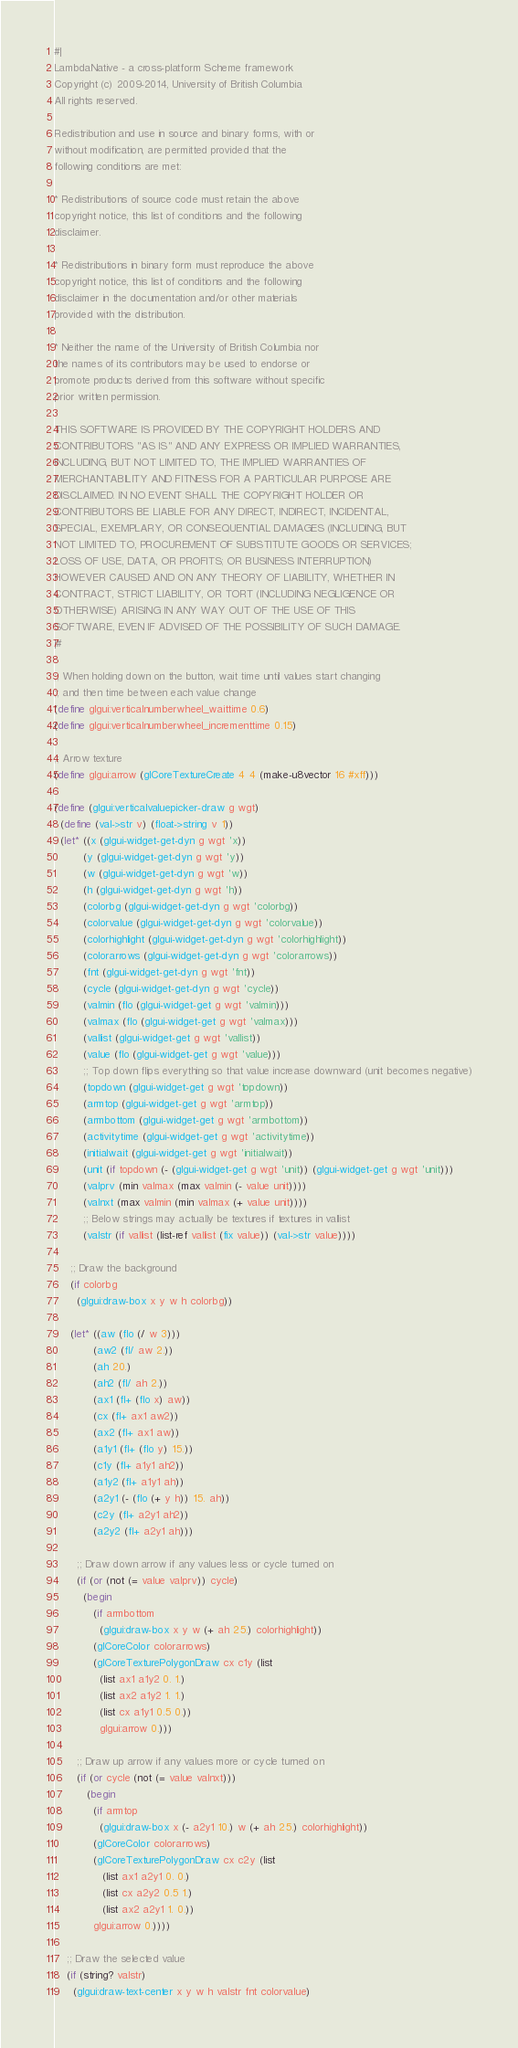<code> <loc_0><loc_0><loc_500><loc_500><_Scheme_>#|
LambdaNative - a cross-platform Scheme framework
Copyright (c) 2009-2014, University of British Columbia
All rights reserved.

Redistribution and use in source and binary forms, with or
without modification, are permitted provided that the
following conditions are met:

* Redistributions of source code must retain the above
copyright notice, this list of conditions and the following
disclaimer.

* Redistributions in binary form must reproduce the above
copyright notice, this list of conditions and the following
disclaimer in the documentation and/or other materials
provided with the distribution.

* Neither the name of the University of British Columbia nor
the names of its contributors may be used to endorse or
promote products derived from this software without specific
prior written permission.

THIS SOFTWARE IS PROVIDED BY THE COPYRIGHT HOLDERS AND
CONTRIBUTORS "AS IS" AND ANY EXPRESS OR IMPLIED WARRANTIES,
INCLUDING, BUT NOT LIMITED TO, THE IMPLIED WARRANTIES OF
MERCHANTABILITY AND FITNESS FOR A PARTICULAR PURPOSE ARE
DISCLAIMED. IN NO EVENT SHALL THE COPYRIGHT HOLDER OR
CONTRIBUTORS BE LIABLE FOR ANY DIRECT, INDIRECT, INCIDENTAL,
SPECIAL, EXEMPLARY, OR CONSEQUENTIAL DAMAGES (INCLUDING, BUT
NOT LIMITED TO, PROCUREMENT OF SUBSTITUTE GOODS OR SERVICES;
LOSS OF USE, DATA, OR PROFITS; OR BUSINESS INTERRUPTION)
HOWEVER CAUSED AND ON ANY THEORY OF LIABILITY, WHETHER IN
CONTRACT, STRICT LIABILITY, OR TORT (INCLUDING NEGLIGENCE OR
OTHERWISE) ARISING IN ANY WAY OUT OF THE USE OF THIS
SOFTWARE, EVEN IF ADVISED OF THE POSSIBILITY OF SUCH DAMAGE.
|#

;; When holding down on the button, wait time until values start changing
;; and then time between each value change 
(define glgui:verticalnumberwheel_waittime 0.6)
(define glgui:verticalnumberwheel_incrementtime 0.15)

;; Arrow texture
(define glgui:arrow (glCoreTextureCreate 4 4 (make-u8vector 16 #xff)))

(define (glgui:verticalvaluepicker-draw g wgt)
  (define (val->str v) (float->string v 1))
  (let* ((x (glgui-widget-get-dyn g wgt 'x))
         (y (glgui-widget-get-dyn g wgt 'y))
         (w (glgui-widget-get-dyn g wgt 'w))
         (h (glgui-widget-get-dyn g wgt 'h))
         (colorbg (glgui-widget-get-dyn g wgt 'colorbg))
         (colorvalue (glgui-widget-get-dyn g wgt 'colorvalue))
         (colorhighlight (glgui-widget-get-dyn g wgt 'colorhighlight))
         (colorarrows (glgui-widget-get-dyn g wgt 'colorarrows))
         (fnt (glgui-widget-get-dyn g wgt 'fnt))
         (cycle (glgui-widget-get-dyn g wgt 'cycle))
         (valmin (flo (glgui-widget-get g wgt 'valmin)))
         (valmax (flo (glgui-widget-get g wgt 'valmax)))
         (vallist (glgui-widget-get g wgt 'vallist))
         (value (flo (glgui-widget-get g wgt 'value)))
         ;; Top down flips everything so that value increase downward (unit becomes negative)
         (topdown (glgui-widget-get g wgt 'topdown))
         (armtop (glgui-widget-get g wgt 'armtop))
         (armbottom (glgui-widget-get g wgt 'armbottom))
         (activitytime (glgui-widget-get g wgt 'activitytime))
         (initialwait (glgui-widget-get g wgt 'initialwait))
         (unit (if topdown (- (glgui-widget-get g wgt 'unit)) (glgui-widget-get g wgt 'unit)))
         (valprv (min valmax (max valmin (- value unit))))
         (valnxt (max valmin (min valmax (+ value unit))))
         ;; Below strings may actually be textures if textures in vallist
         (valstr (if vallist (list-ref vallist (fix value)) (val->str value))))

     ;; Draw the background
     (if colorbg
       (glgui:draw-box x y w h colorbg))

     (let* ((aw (flo (/ w 3)))
            (aw2 (fl/ aw 2.))
            (ah 20.)
            (ah2 (fl/ ah 2.))
            (ax1 (fl+ (flo x) aw))
            (cx (fl+ ax1 aw2))
            (ax2 (fl+ ax1 aw))
            (a1y1 (fl+ (flo y) 15.))
            (c1y (fl+ a1y1 ah2))
            (a1y2 (fl+ a1y1 ah))
            (a2y1 (- (flo (+ y h)) 15. ah))
            (c2y (fl+ a2y1 ah2))
            (a2y2 (fl+ a2y1 ah)))
     
       ;; Draw down arrow if any values less or cycle turned on
       (if (or (not (= value valprv)) cycle) 
         (begin
            (if armbottom
              (glgui:draw-box x y w (+ ah 25.) colorhighlight))
            (glCoreColor colorarrows)
            (glCoreTexturePolygonDraw cx c1y (list 
              (list ax1 a1y2 0. 1.)
              (list ax2 a1y2 1. 1.)
              (list cx a1y1 0.5 0.))
              glgui:arrow 0.)))

       ;; Draw up arrow if any values more or cycle turned on
       (if (or cycle (not (= value valnxt))) 
          (begin
            (if armtop
              (glgui:draw-box x (- a2y1 10.) w (+ ah 25.) colorhighlight))
            (glCoreColor colorarrows)
            (glCoreTexturePolygonDraw cx c2y (list
               (list ax1 a2y1 0. 0.)
               (list cx a2y2 0.5 1.)
               (list ax2 a2y1 1. 0.))
            glgui:arrow 0.))))
        
    ;; Draw the selected value
    (if (string? valstr) 
      (glgui:draw-text-center x y w h valstr fnt colorvalue)</code> 